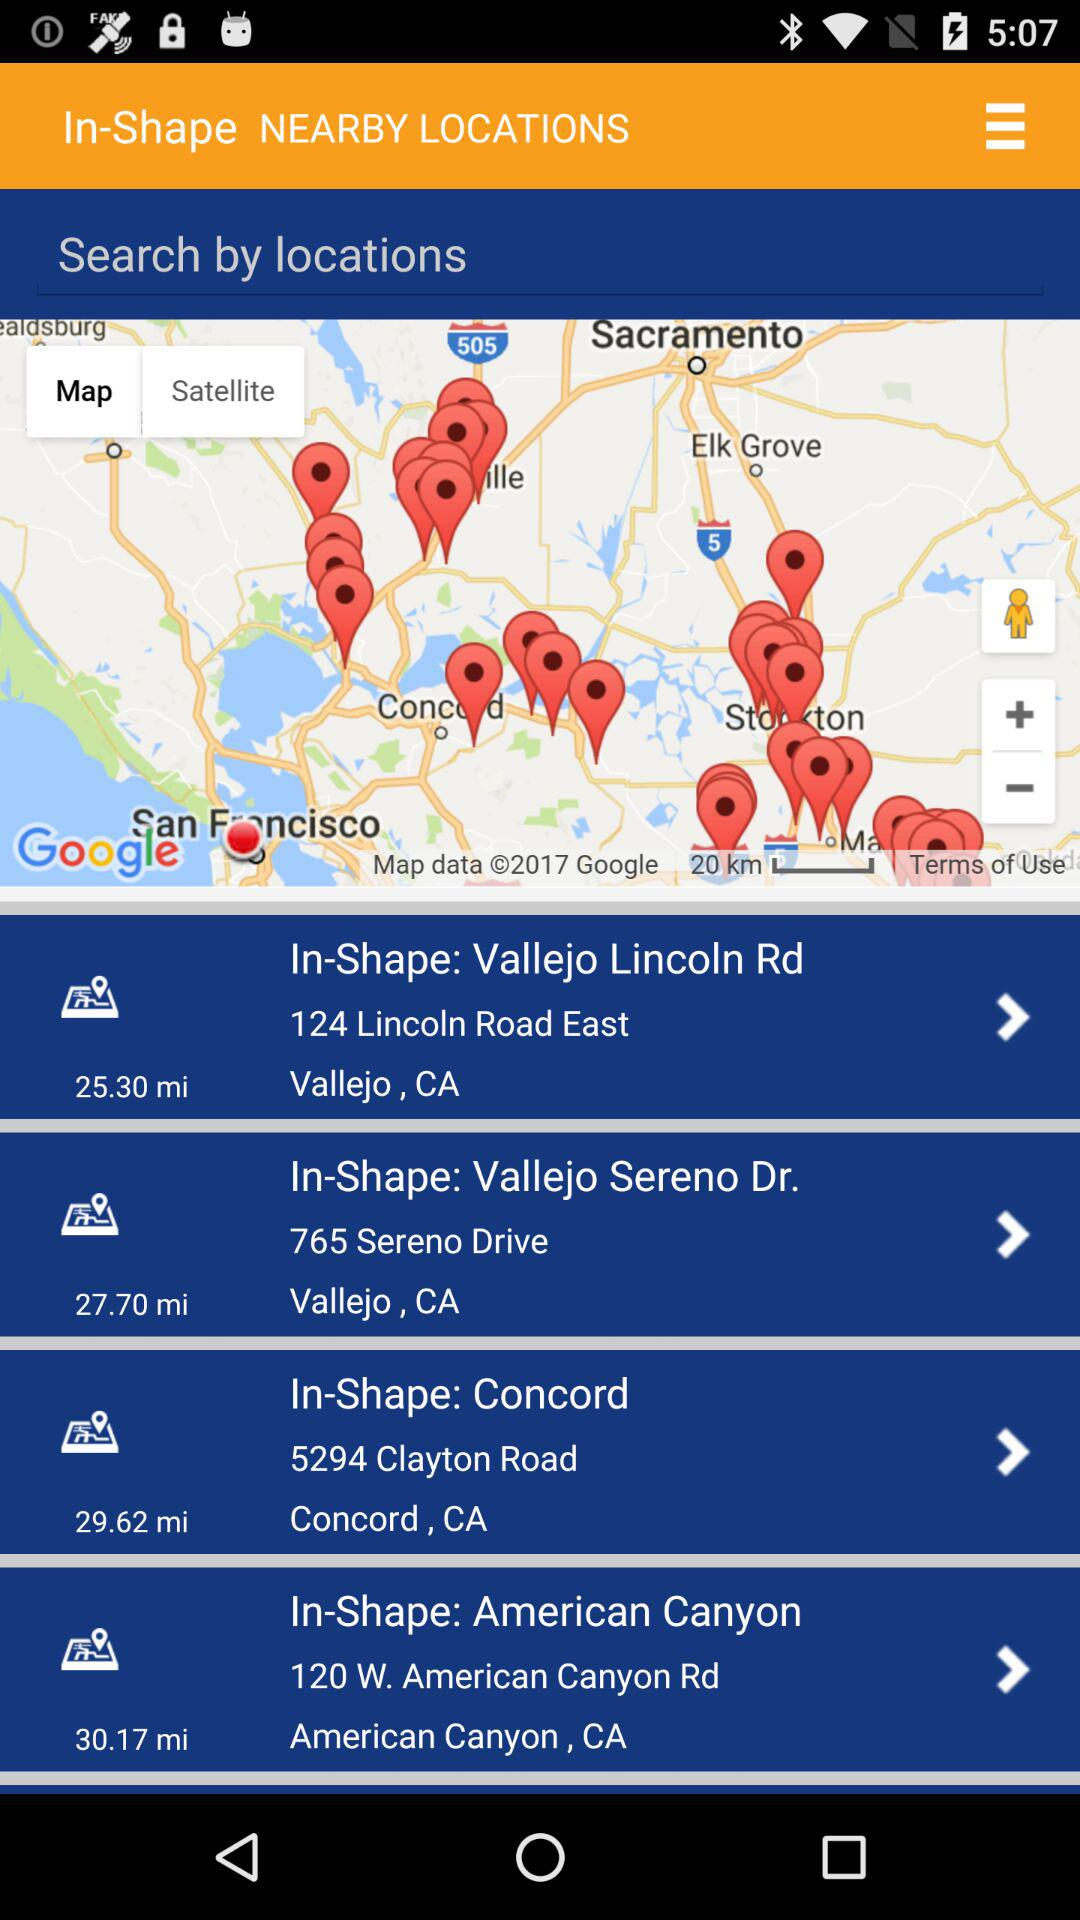Which location is 27.70 miles away? 27.70 miles away, the location is In-Shape: Vallejo Sereno Dr., 765 Sereno Drive, Vallejo, CA. 